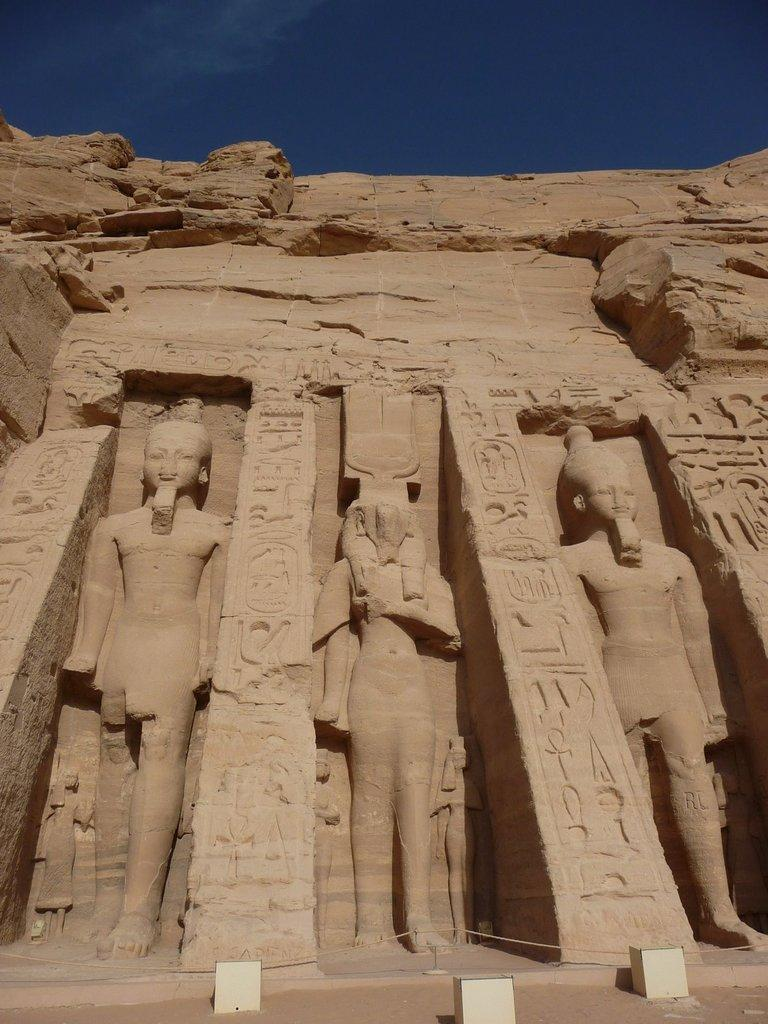What is the main subject in the center of the image? There are sculptures in the center of the image. What can be seen in the background of the image? There is a wall in the image. What is located at the bottom of the image? There are boxes and a walkway at the bottom of the image. What is visible at the top of the image? The sky is visible at the top of the image. Where is the tank located in the image? There is no tank present in the image. What type of impulse can be seen affecting the sculptures in the image? There is no impulse affecting the sculptures in the image; they are stationary. 